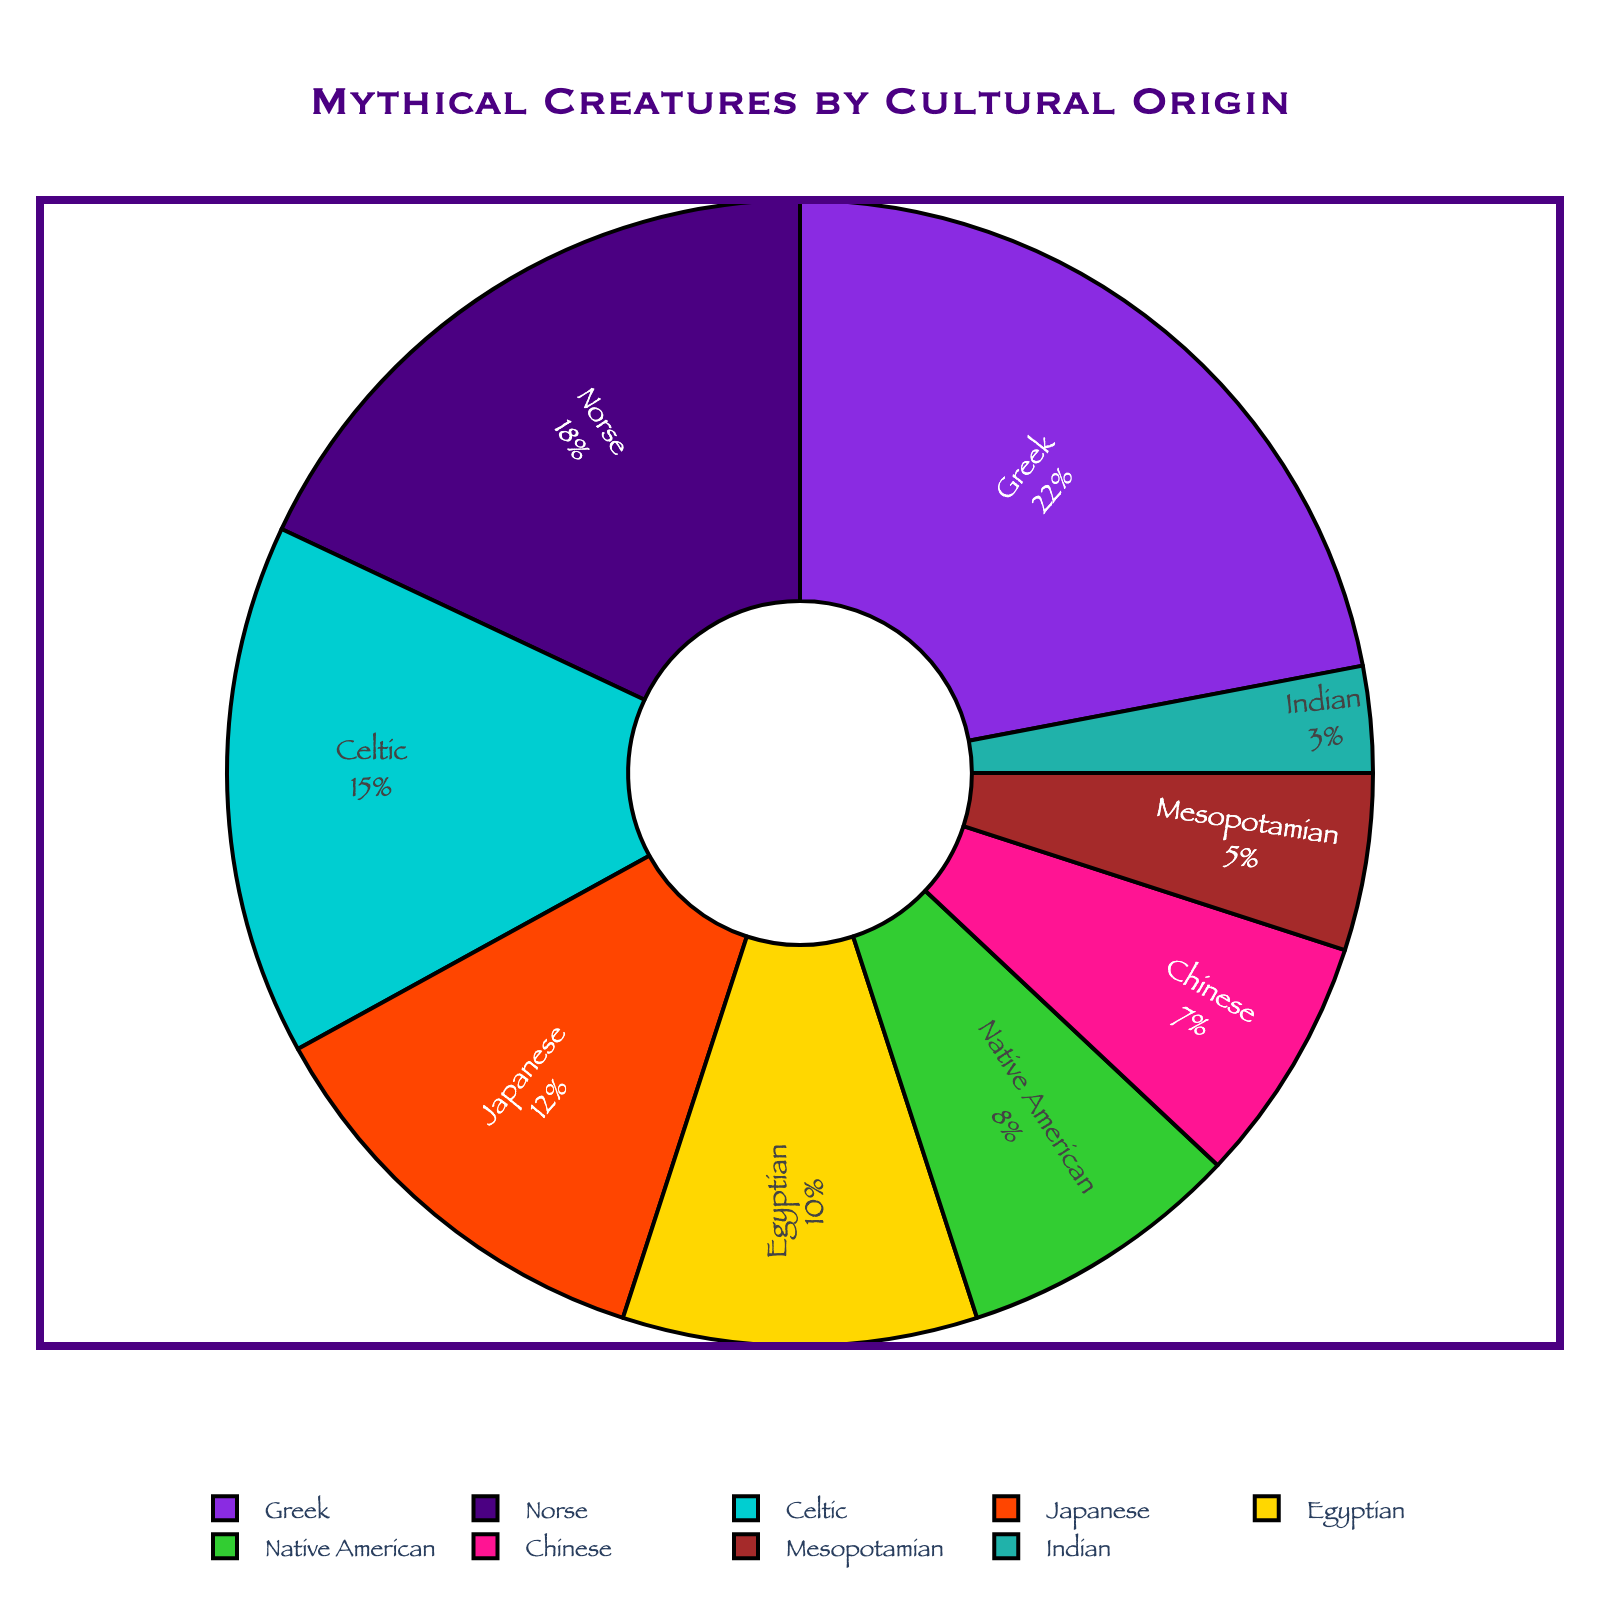What's the most common cultural origin of mythical creatures? According to the pie chart, the largest segment represents Greek mythical creatures. The percentage of Greek mythical creatures is 22%, which is the highest.
Answer: Greek How much greater is the percentage of Greek mythical creatures compared to Celtic ones? The percentage of Greek mythical creatures is 22%, and the percentage of Celtic mythical creatures is 15%. To find the difference, subtract 15 from 22: 22 - 15 = 7.
Answer: 7% Which cultural origin has the least representation of mythical creatures, and what is its percentage? The smallest segment in the pie chart represents Indian mythical creatures, which have a percentage of 3%.
Answer: Indian, 3% Are Japanese mythical creatures more or less common than Egyptian ones? Japanese mythical creatures have a percentage of 12%, while Egyptian ones have 10%. Since 12% is greater than 10%, Japanese mythical creatures are more common.
Answer: More common What is the combined percentage of Norse, Celtic, and Japanese mythical creatures? The percentages for Norse, Celtic, and Japanese mythical creatures are 18%, 15%, and 12%, respectively. Add these values together: 18 + 15 + 12 = 45.
Answer: 45% Which cultural origins have a representation of 10% or higher? Reviewing the segments, the cultural origins with 10% or higher are Greek (22%), Norse (18%), Celtic (15%), Japanese (12%), and Egyptian (10%).
Answer: Greek, Norse, Celtic, Japanese, Egyptian Compare Native American and Mesopotamian mythical creatures in terms of their percentages. The percentage for Native American mythical creatures is 8%, and for Mesopotamian mythical creatures, it is 5%. Native American mythical creatures are more common than Mesopotamian ones.
Answer: Native American, 8% What is the average percentage of mythical creatures from Greek, Norse, and Celtic origins? The percentages for Greek, Norse, and Celtic origins are 22%, 18%, and 15%, respectively. To find the average, sum these values and divide by 3: (22 + 18 + 15) / 3 = 18.33.
Answer: 18.33% Which has a higher percentage, Chinese or Egyptian mythical creatures, and by how much? The percentage of Egyptian mythical creatures is 10%, and Chinese mythical creatures have 7%. To find the difference, subtract 7 from 10: 10 - 7 = 3. Egyptian mythical creatures have a higher percentage by 3%.
Answer: Egyptian, 3% What is the combined percentage of the least represented cultural origins (Chinese, Mesopotamian, and Indian)? The percentages for Chinese, Mesopotamian, and Indian origins are 7%, 5%, and 3%, respectively. Add these values together: 7 + 5 + 3 = 15.
Answer: 15% 